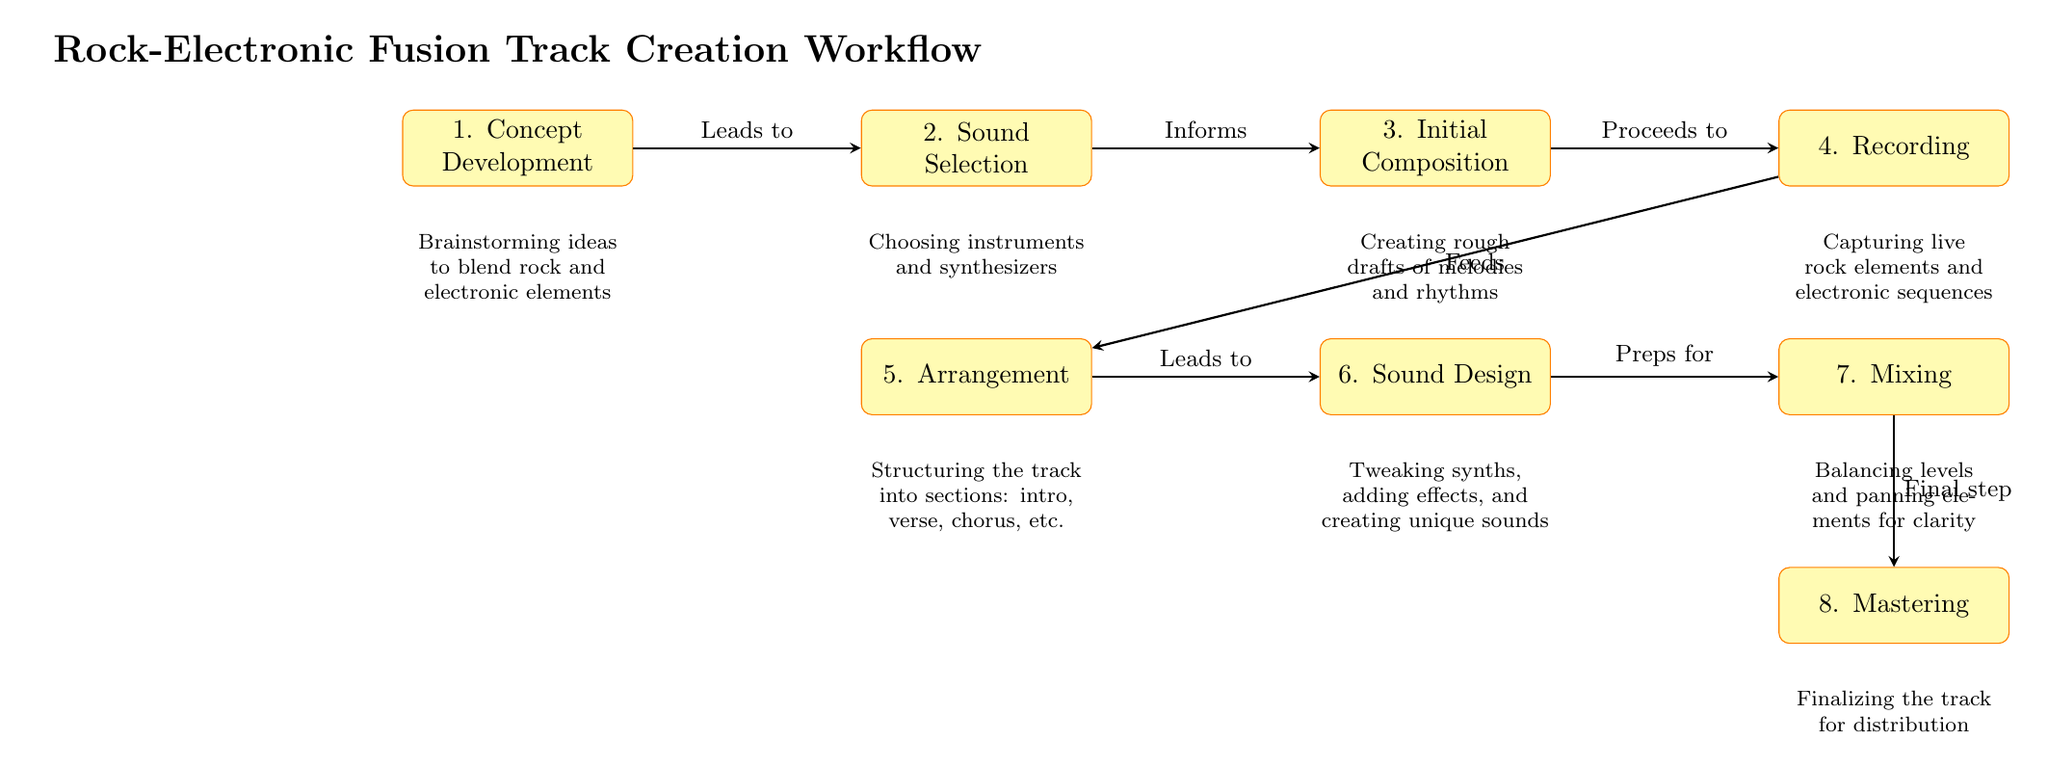What is the first step in the workflow? The first step in the workflow is detailed in the node labeled "1. Concept Development". This node outlines the initial phase of brainstorming ideas to blend rock and electronic elements.
Answer: Concept Development Which process immediately follows the "Sound Selection"? The process that immediately follows "Sound Selection" is "Initial Composition", as indicated by the arrow connecting the two nodes. This shows the progression from selecting sounds to composing the track.
Answer: Initial Composition How many main processes are outlined in the diagram? The diagram outlines eight main processes, from the "Concept Development" to the "Mastering" phase, which are clearly marked as individual nodes in the workflow.
Answer: Eight What does the "Recording" process feed into? The "Recording" process feeds into the "Arrangement" process, as indicated by the arrow pointing from "Recording" to "Arrangement". This illustrates the flow of actions in creating the track.
Answer: Arrangement What is the final step in the workflow? The final step in the workflow is labeled "Mastering". This indicates that mastering is the last process before the track is finalized for distribution.
Answer: Mastering Which step leads to "Sound Design"? The step that leads to "Sound Design" is "Arrangement". The diagram shows a direct connection where arrangement influences the subsequent sound design process.
Answer: Arrangement What kind of ideas are being brainstormed in the first step? The first step involves brainstorming ideas specifically to blend rock and electronic elements; this is mentioned in the description below the "Concept Development" node.
Answer: Rock and electronic elements Which process involves balancing levels and panning elements? The process that involves balancing levels and panning is "Mixing". The description under this node explains the work done during the mixing phase to achieve clarity in the track.
Answer: Mixing 